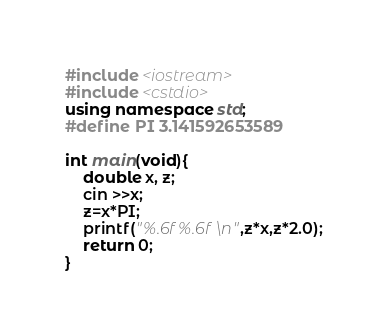Convert code to text. <code><loc_0><loc_0><loc_500><loc_500><_C++_>#include <iostream>
#include <cstdio>
using namespace std;
#define PI 3.141592653589

int main(void){
    double x, z;
    cin >>x;
    z=x*PI;
    printf("%.6f %.6f\n",z*x,z*2.0); 
    return 0;
}</code> 